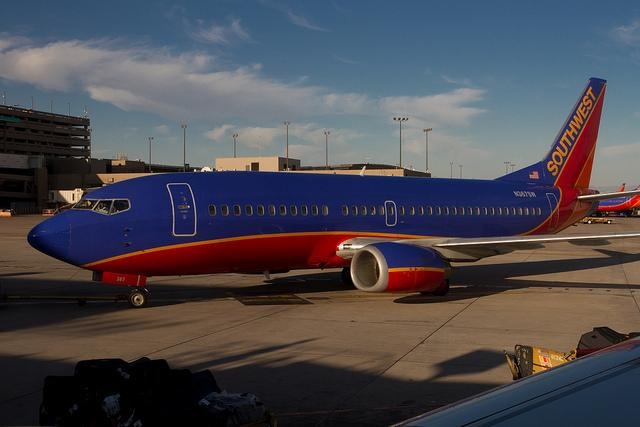What is the blue plane used for?

Choices:
A) commercial travel
B) cargo shipping
C) military exercises
D) racing commercial travel 